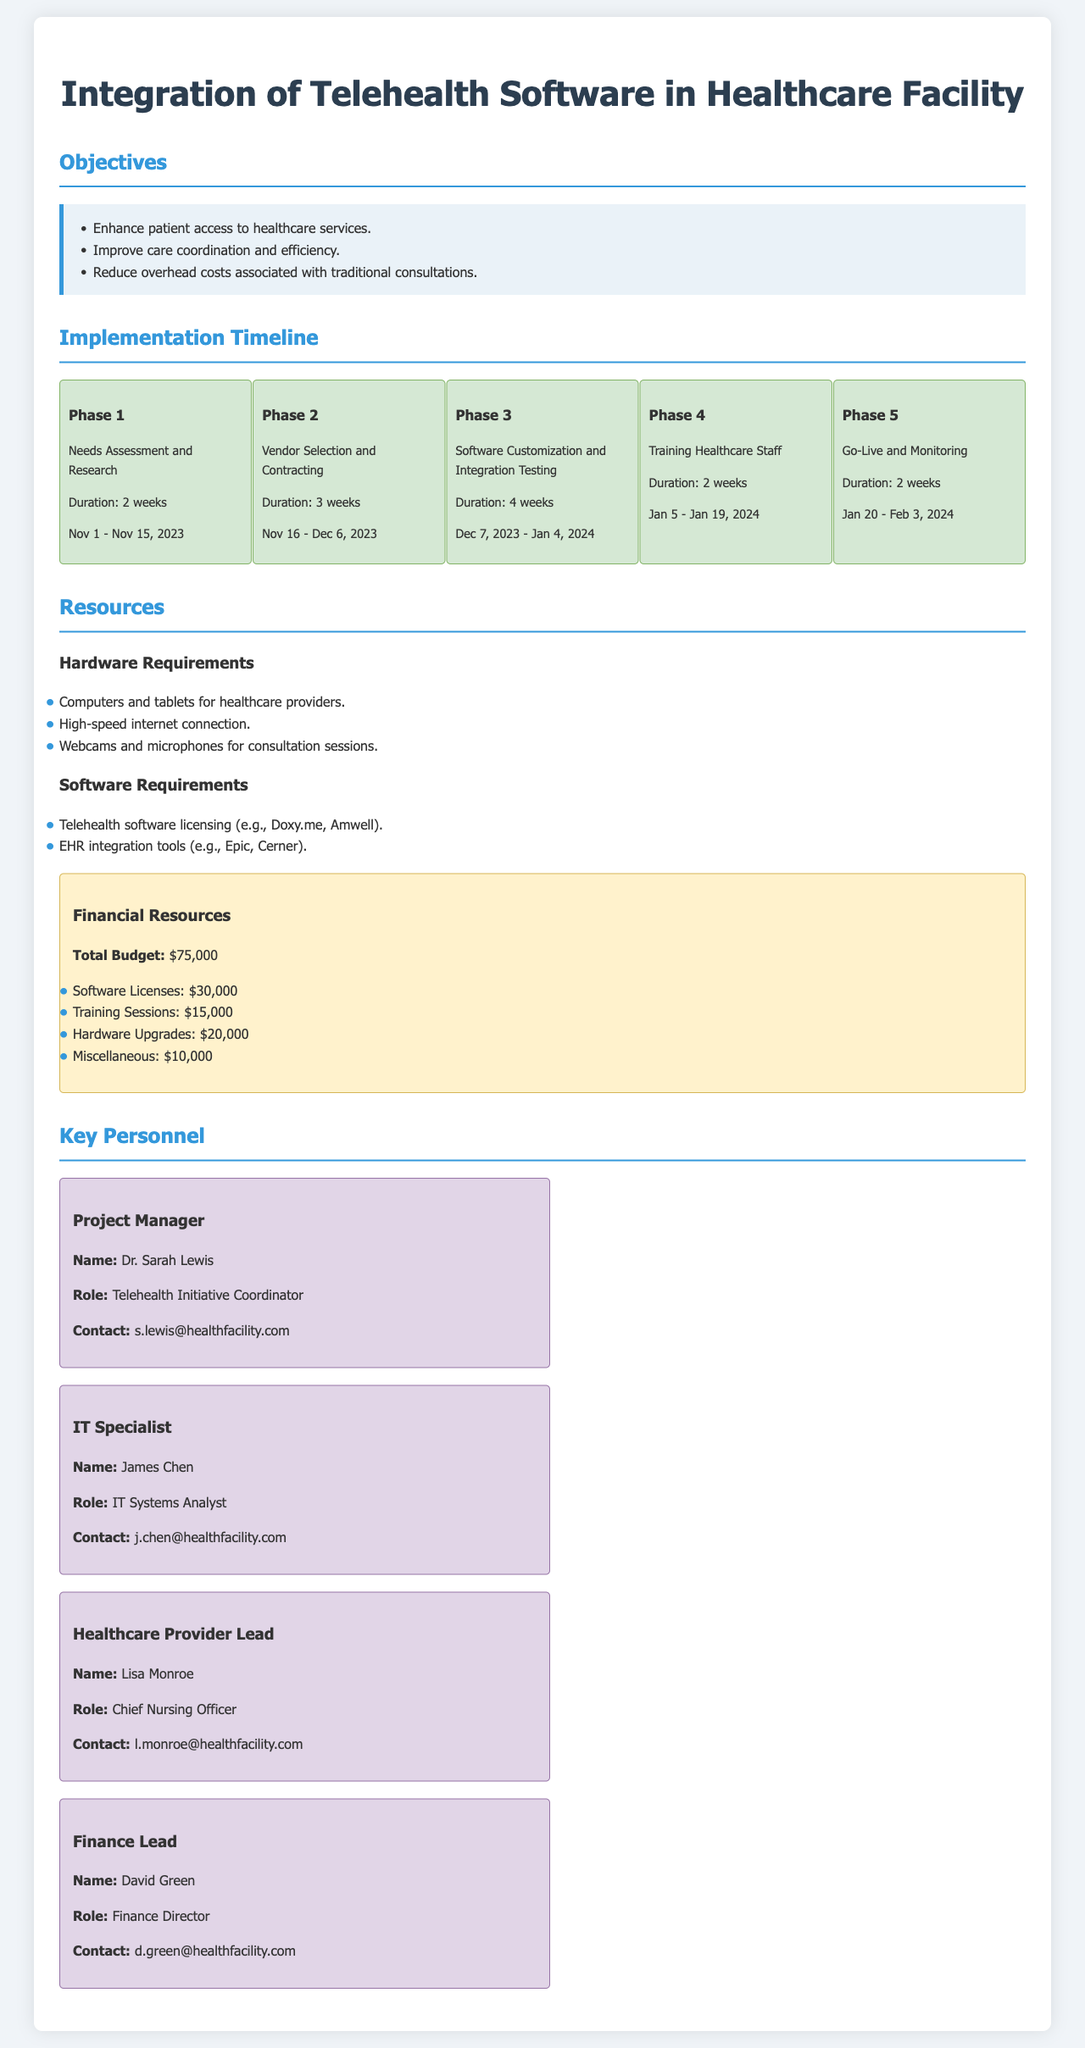What is the total budget for the telehealth integration? The total budget is listed in the financial resources section of the document.
Answer: $75,000 Who is the Project Manager? The name and title of the Project Manager are outlined in the key personnel section of the document.
Answer: Dr. Sarah Lewis What is the duration of Phase 3? The duration for Phase 3 is provided in the implementation timeline.
Answer: 4 weeks What is the start date for Phase 2? The start date for Phase 2 is mentioned in the implementation timeline.
Answer: November 16, 2023 What role does James Chen hold? The role of James Chen is specified in the key personnel section of the document.
Answer: IT Systems Analyst What is a primary objective of integrating telehealth software? The objectives are listed in a dedicated section of the document.
Answer: Enhance patient access to healthcare services During which phase does staff training occur? The phase for training healthcare staff is described in the implementation timeline.
Answer: Phase 4 What is one of the hardware requirements for telehealth? Hardware requirements are outlined in a specific section of the document.
Answer: High-speed internet connection What is the contact email for Lisa Monroe? Lisa Monroe's contact information is provided in the key personnel section.
Answer: l.monroe@healthfacility.com 